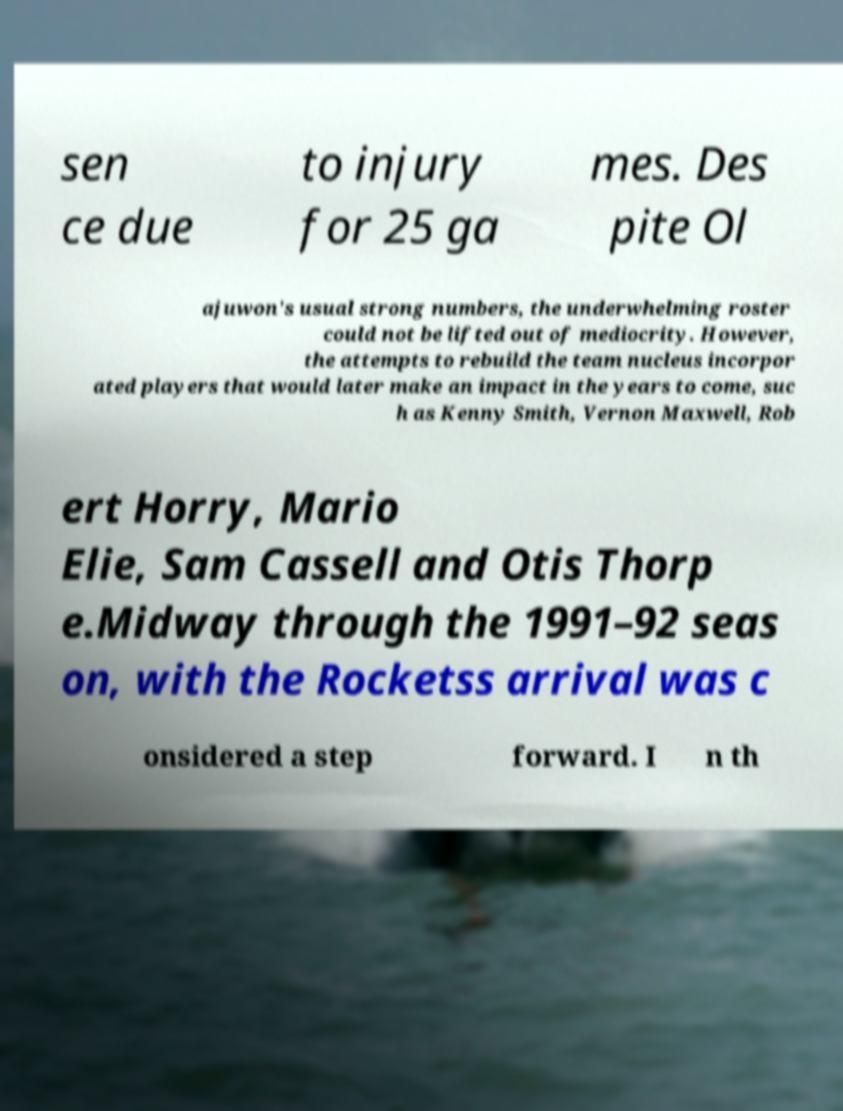Could you assist in decoding the text presented in this image and type it out clearly? sen ce due to injury for 25 ga mes. Des pite Ol ajuwon's usual strong numbers, the underwhelming roster could not be lifted out of mediocrity. However, the attempts to rebuild the team nucleus incorpor ated players that would later make an impact in the years to come, suc h as Kenny Smith, Vernon Maxwell, Rob ert Horry, Mario Elie, Sam Cassell and Otis Thorp e.Midway through the 1991–92 seas on, with the Rocketss arrival was c onsidered a step forward. I n th 